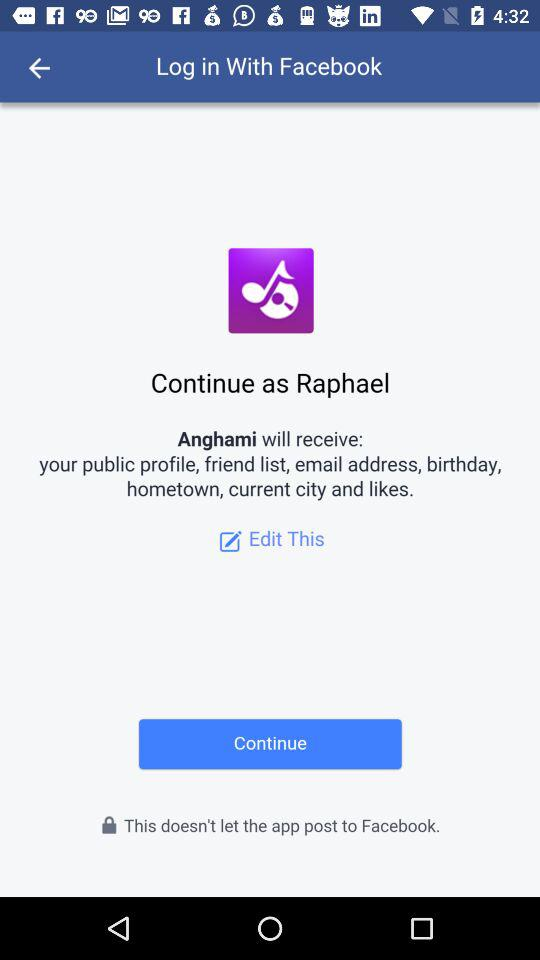Which application is asking for permission? The application that is asking for permission is "Anghami". 